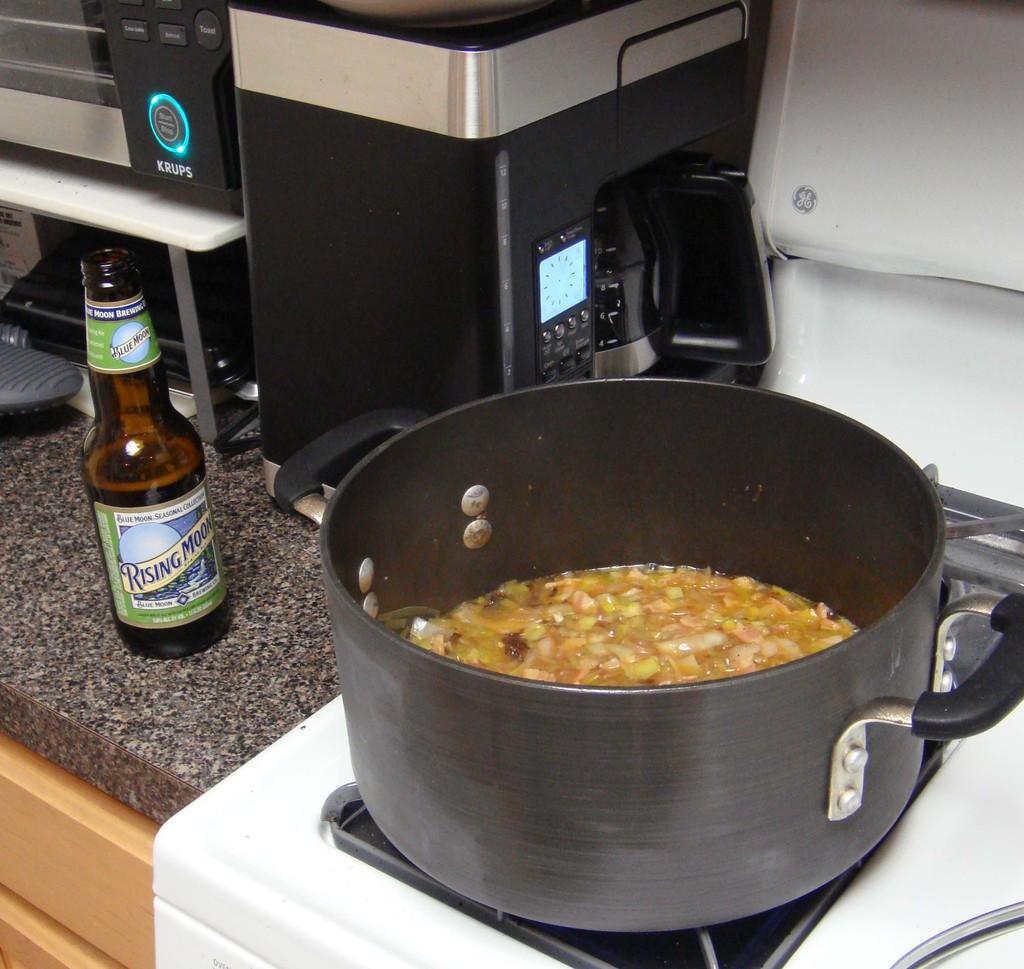What kind of beer is in the bottle?
Your answer should be compact. Rising moon. 